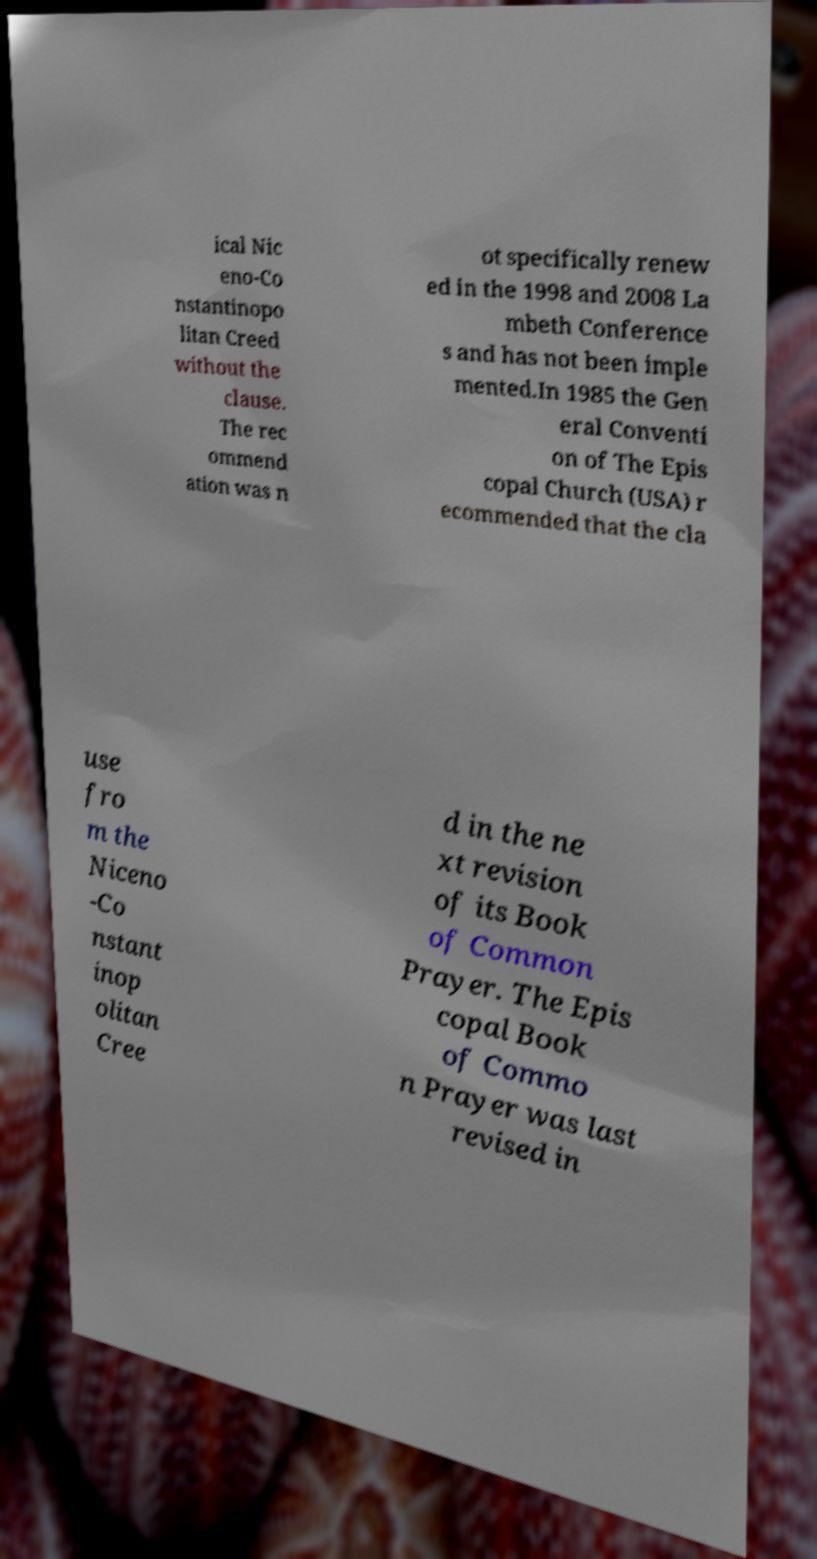Could you extract and type out the text from this image? ical Nic eno-Co nstantinopo litan Creed without the clause. The rec ommend ation was n ot specifically renew ed in the 1998 and 2008 La mbeth Conference s and has not been imple mented.In 1985 the Gen eral Conventi on of The Epis copal Church (USA) r ecommended that the cla use fro m the Niceno -Co nstant inop olitan Cree d in the ne xt revision of its Book of Common Prayer. The Epis copal Book of Commo n Prayer was last revised in 